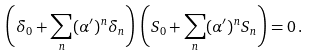Convert formula to latex. <formula><loc_0><loc_0><loc_500><loc_500>\left ( \delta _ { 0 } + \sum _ { n } ( \alpha ^ { \prime } ) ^ { n } \delta _ { n } \right ) \, \left ( S _ { 0 } + \sum _ { n } ( \alpha ^ { \prime } ) ^ { n } S _ { n } \right ) = 0 \, .</formula> 